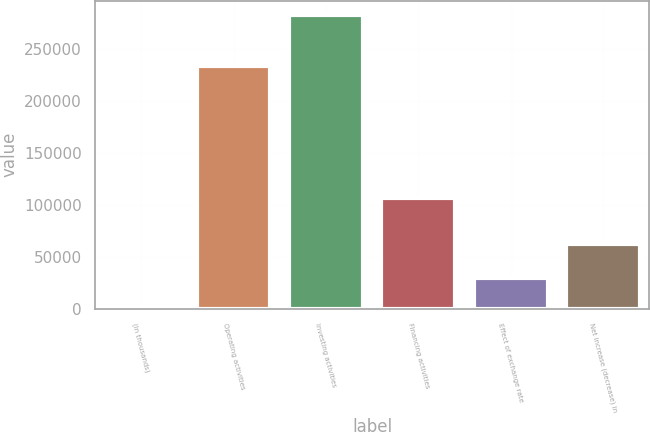Convert chart. <chart><loc_0><loc_0><loc_500><loc_500><bar_chart><fcel>(In thousands)<fcel>Operating activities<fcel>Investing activities<fcel>Financing activities<fcel>Effect of exchange rate<fcel>Net increase (decrease) in<nl><fcel>2017<fcel>234063<fcel>282987<fcel>106759<fcel>30114<fcel>62013<nl></chart> 